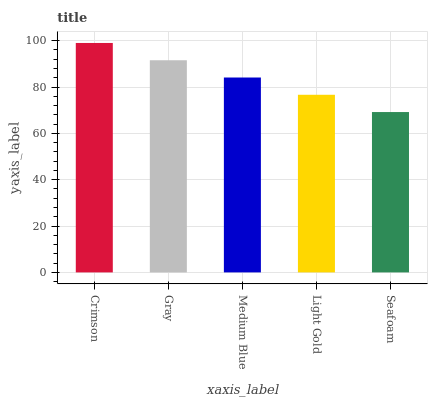Is Seafoam the minimum?
Answer yes or no. Yes. Is Crimson the maximum?
Answer yes or no. Yes. Is Gray the minimum?
Answer yes or no. No. Is Gray the maximum?
Answer yes or no. No. Is Crimson greater than Gray?
Answer yes or no. Yes. Is Gray less than Crimson?
Answer yes or no. Yes. Is Gray greater than Crimson?
Answer yes or no. No. Is Crimson less than Gray?
Answer yes or no. No. Is Medium Blue the high median?
Answer yes or no. Yes. Is Medium Blue the low median?
Answer yes or no. Yes. Is Light Gold the high median?
Answer yes or no. No. Is Light Gold the low median?
Answer yes or no. No. 